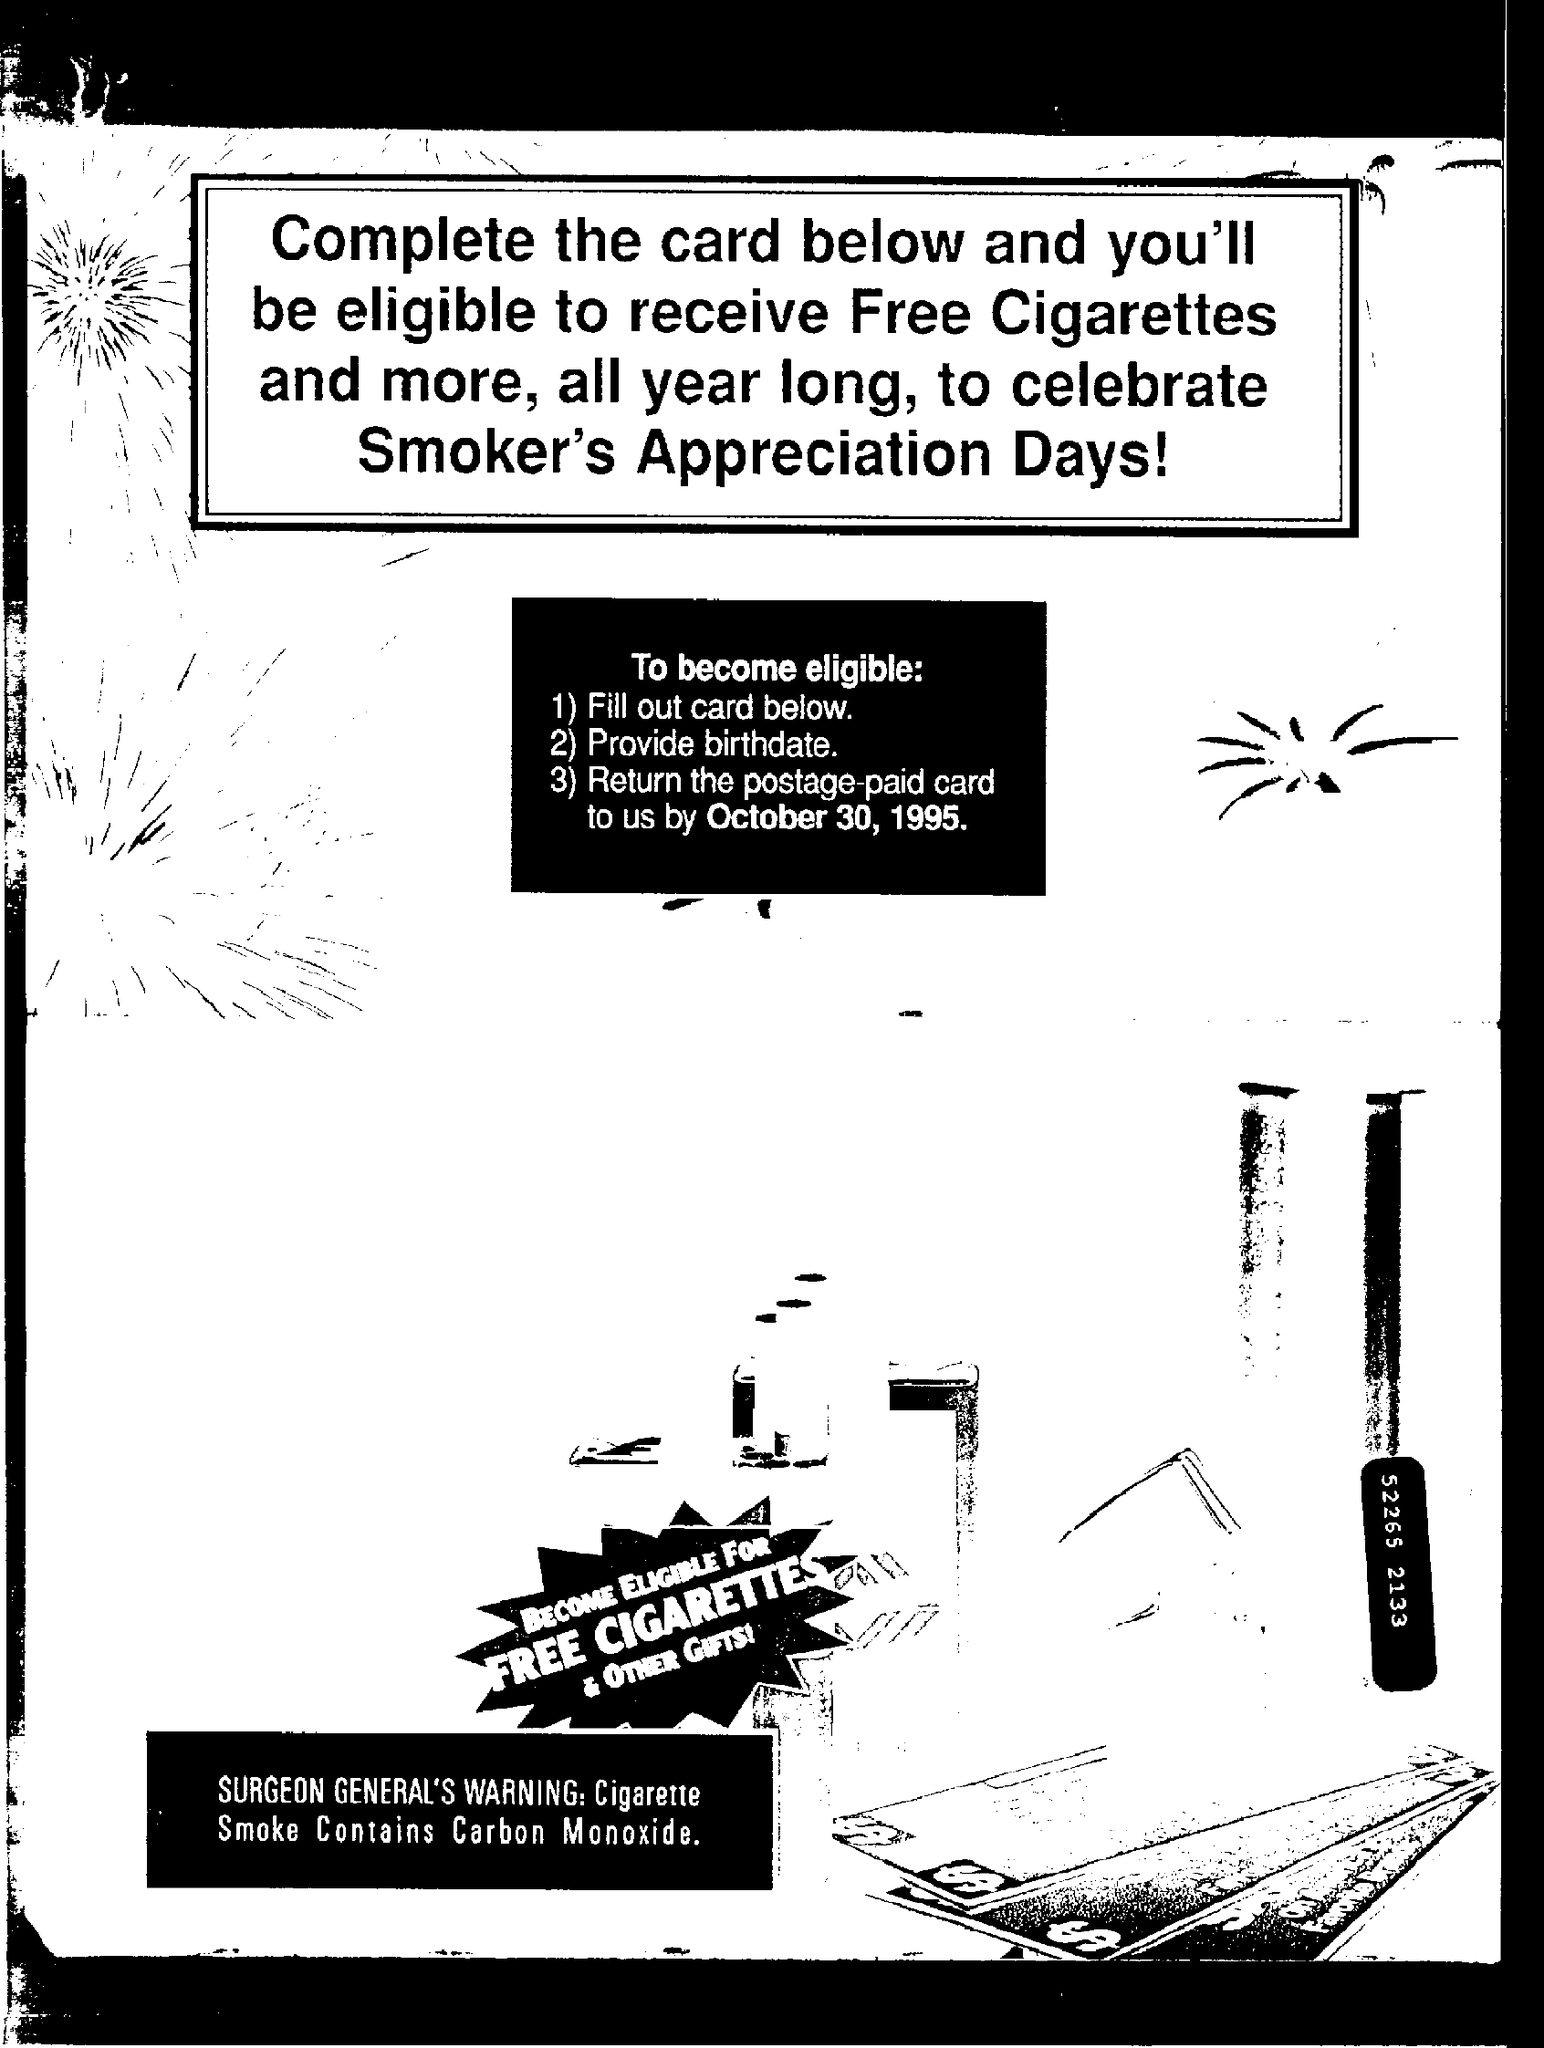What does cigarette smoke contain ?
Ensure brevity in your answer.  Carbon monoxide. 